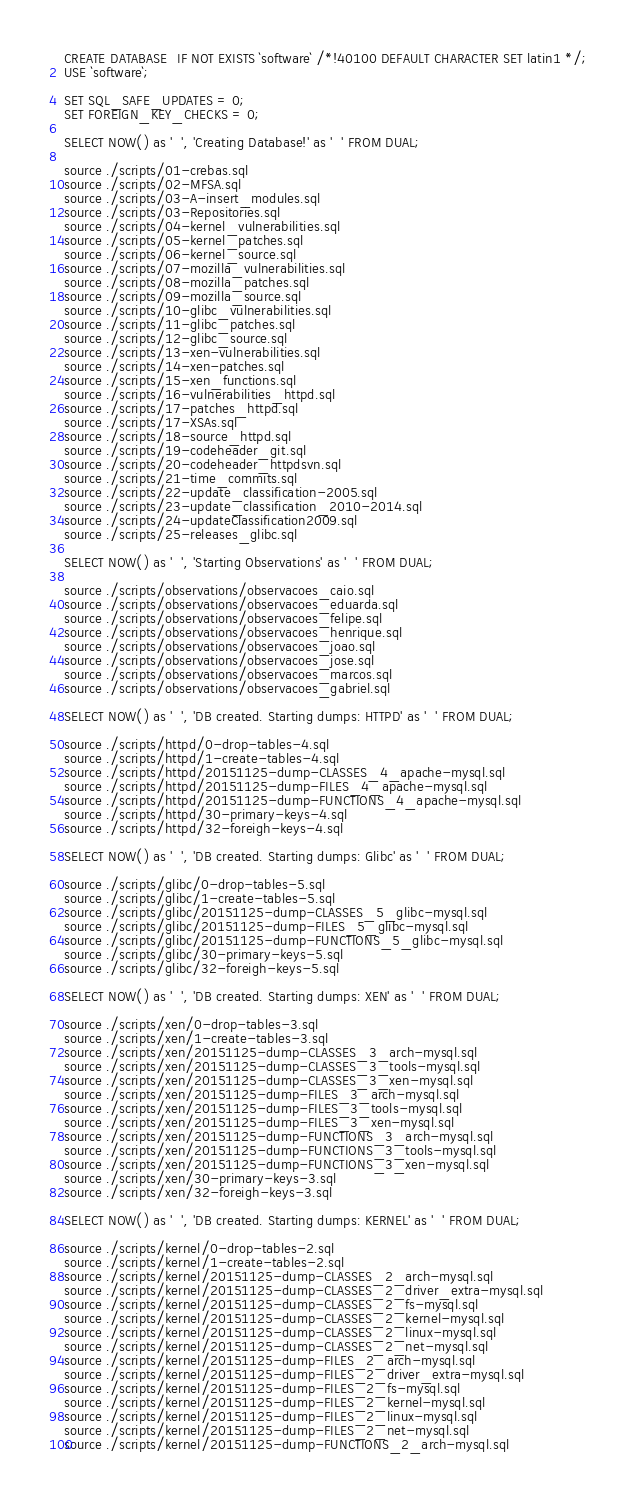<code> <loc_0><loc_0><loc_500><loc_500><_SQL_>CREATE DATABASE  IF NOT EXISTS `software` /*!40100 DEFAULT CHARACTER SET latin1 */;
USE `software`;

SET SQL_SAFE_UPDATES = 0;
SET FOREIGN_KEY_CHECKS = 0;

SELECT NOW() as '  ', 'Creating Database!' as '  ' FROM DUAL;

source ./scripts/01-crebas.sql
source ./scripts/02-MFSA.sql
source ./scripts/03-A-insert_modules.sql
source ./scripts/03-Repositories.sql
source ./scripts/04-kernel_vulnerabilities.sql
source ./scripts/05-kernel_patches.sql
source ./scripts/06-kernel_source.sql
source ./scripts/07-mozilla_vulnerabilities.sql
source ./scripts/08-mozilla_patches.sql
source ./scripts/09-mozilla_source.sql
source ./scripts/10-glibc_vulnerabilities.sql
source ./scripts/11-glibc_patches.sql
source ./scripts/12-glibc_source.sql
source ./scripts/13-xen-vulnerabilities.sql
source ./scripts/14-xen-patches.sql
source ./scripts/15-xen_functions.sql
source ./scripts/16-vulnerabilities_httpd.sql
source ./scripts/17-patches_httpd.sql
source ./scripts/17-XSAs.sql
source ./scripts/18-source_httpd.sql
source ./scripts/19-codeheader_git.sql
source ./scripts/20-codeheader_httpdsvn.sql
source ./scripts/21-time_commits.sql
source ./scripts/22-update_classification-2005.sql
source ./scripts/23-update_classification_2010-2014.sql
source ./scripts/24-updateClassification2009.sql
source ./scripts/25-releases_glibc.sql

SELECT NOW() as '  ', 'Starting Observations' as '  ' FROM DUAL;

source ./scripts/observations/observacoes_caio.sql
source ./scripts/observations/observacoes_eduarda.sql
source ./scripts/observations/observacoes_felipe.sql
source ./scripts/observations/observacoes_henrique.sql
source ./scripts/observations/observacoes_joao.sql
source ./scripts/observations/observacoes_jose.sql
source ./scripts/observations/observacoes_marcos.sql
source ./scripts/observations/observacoes_gabriel.sql

SELECT NOW() as '  ', 'DB created. Starting dumps: HTTPD' as '  ' FROM DUAL;

source ./scripts/httpd/0-drop-tables-4.sql
source ./scripts/httpd/1-create-tables-4.sql
source ./scripts/httpd/20151125-dump-CLASSES_4_apache-mysql.sql
source ./scripts/httpd/20151125-dump-FILES_4_apache-mysql.sql
source ./scripts/httpd/20151125-dump-FUNCTIONS_4_apache-mysql.sql
source ./scripts/httpd/30-primary-keys-4.sql
source ./scripts/httpd/32-foreigh-keys-4.sql

SELECT NOW() as '  ', 'DB created. Starting dumps: Glibc' as '  ' FROM DUAL;

source ./scripts/glibc/0-drop-tables-5.sql
source ./scripts/glibc/1-create-tables-5.sql
source ./scripts/glibc/20151125-dump-CLASSES_5_glibc-mysql.sql
source ./scripts/glibc/20151125-dump-FILES_5_glibc-mysql.sql
source ./scripts/glibc/20151125-dump-FUNCTIONS_5_glibc-mysql.sql
source ./scripts/glibc/30-primary-keys-5.sql
source ./scripts/glibc/32-foreigh-keys-5.sql

SELECT NOW() as '  ', 'DB created. Starting dumps: XEN' as '  ' FROM DUAL;

source ./scripts/xen/0-drop-tables-3.sql
source ./scripts/xen/1-create-tables-3.sql
source ./scripts/xen/20151125-dump-CLASSES_3_arch-mysql.sql
source ./scripts/xen/20151125-dump-CLASSES_3_tools-mysql.sql
source ./scripts/xen/20151125-dump-CLASSES_3_xen-mysql.sql
source ./scripts/xen/20151125-dump-FILES_3_arch-mysql.sql
source ./scripts/xen/20151125-dump-FILES_3_tools-mysql.sql
source ./scripts/xen/20151125-dump-FILES_3_xen-mysql.sql
source ./scripts/xen/20151125-dump-FUNCTIONS_3_arch-mysql.sql
source ./scripts/xen/20151125-dump-FUNCTIONS_3_tools-mysql.sql
source ./scripts/xen/20151125-dump-FUNCTIONS_3_xen-mysql.sql
source ./scripts/xen/30-primary-keys-3.sql
source ./scripts/xen/32-foreigh-keys-3.sql

SELECT NOW() as '  ', 'DB created. Starting dumps: KERNEL' as '  ' FROM DUAL;

source ./scripts/kernel/0-drop-tables-2.sql
source ./scripts/kernel/1-create-tables-2.sql
source ./scripts/kernel/20151125-dump-CLASSES_2_arch-mysql.sql
source ./scripts/kernel/20151125-dump-CLASSES_2_driver_extra-mysql.sql
source ./scripts/kernel/20151125-dump-CLASSES_2_fs-mysql.sql
source ./scripts/kernel/20151125-dump-CLASSES_2_kernel-mysql.sql
source ./scripts/kernel/20151125-dump-CLASSES_2_linux-mysql.sql
source ./scripts/kernel/20151125-dump-CLASSES_2_net-mysql.sql
source ./scripts/kernel/20151125-dump-FILES_2_arch-mysql.sql
source ./scripts/kernel/20151125-dump-FILES_2_driver_extra-mysql.sql
source ./scripts/kernel/20151125-dump-FILES_2_fs-mysql.sql
source ./scripts/kernel/20151125-dump-FILES_2_kernel-mysql.sql
source ./scripts/kernel/20151125-dump-FILES_2_linux-mysql.sql
source ./scripts/kernel/20151125-dump-FILES_2_net-mysql.sql
source ./scripts/kernel/20151125-dump-FUNCTIONS_2_arch-mysql.sql</code> 